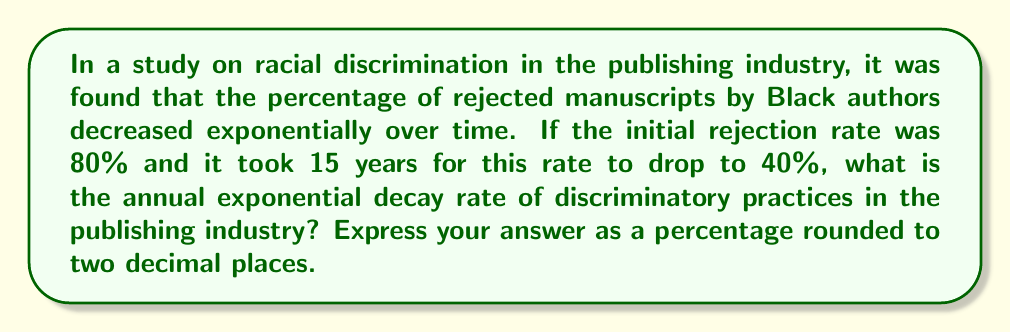Help me with this question. Let's approach this step-by-step using the exponential decay formula:

1) The general form of exponential decay is:
   $A = A_0 \cdot e^{-rt}$

   Where:
   $A$ is the final amount
   $A_0$ is the initial amount
   $r$ is the decay rate
   $t$ is the time

2) In this case:
   $A_0 = 80\%$ (initial rejection rate)
   $A = 40\%$ (final rejection rate after 15 years)
   $t = 15$ years
   We need to solve for $r$

3) Plugging in the values:
   $40 = 80 \cdot e^{-15r}$

4) Divide both sides by 80:
   $\frac{1}{2} = e^{-15r}$

5) Take the natural log of both sides:
   $\ln(\frac{1}{2}) = -15r$

6) Solve for $r$:
   $r = -\frac{\ln(\frac{1}{2})}{15}$

7) Calculate:
   $r = -\frac{-0.6931471806}{15} \approx 0.0462098120$

8) Convert to a percentage:
   $0.0462098120 \times 100 \approx 4.62\%$
Answer: 4.62% 